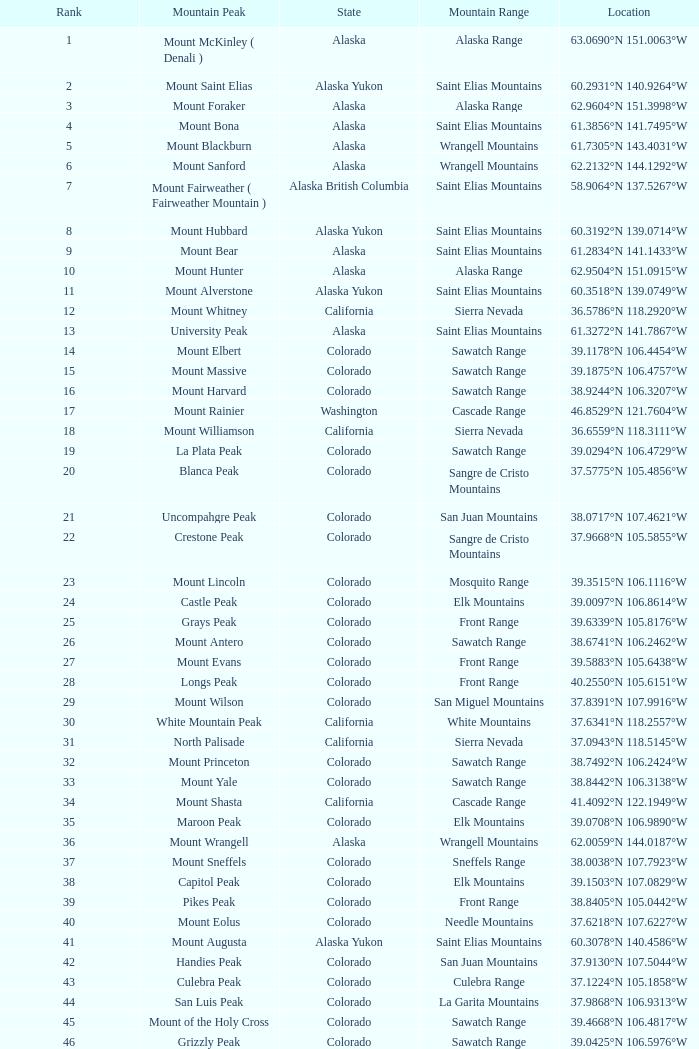What is the rank when the state is colorado and the location is 37.7859°n 107.7039°w? 83.0. 